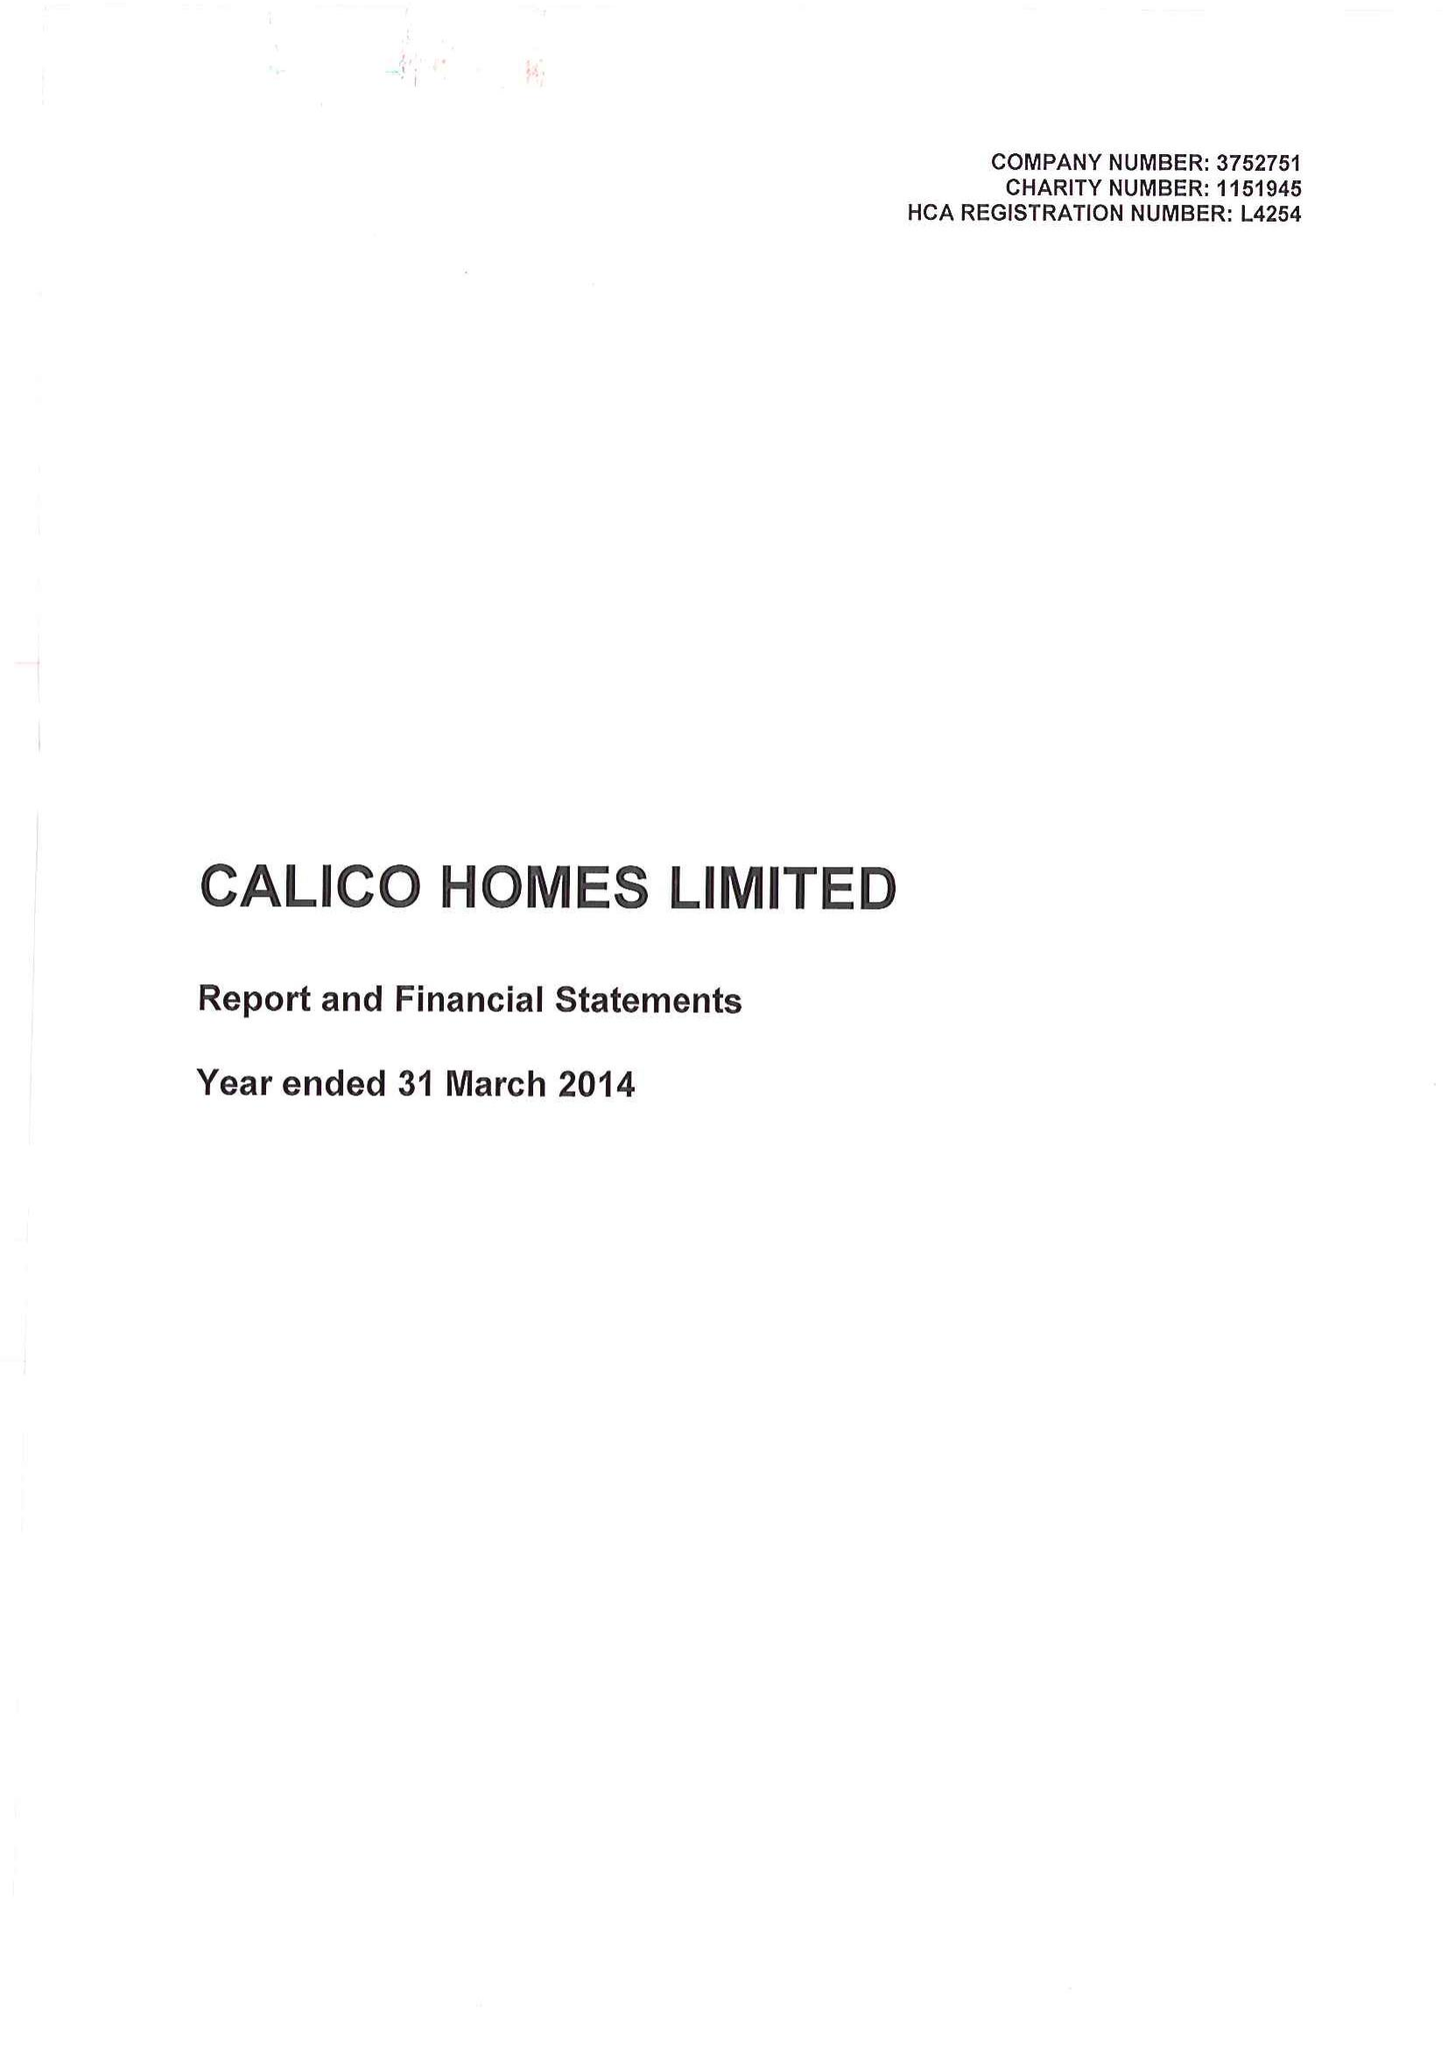What is the value for the charity_number?
Answer the question using a single word or phrase. 1151945 